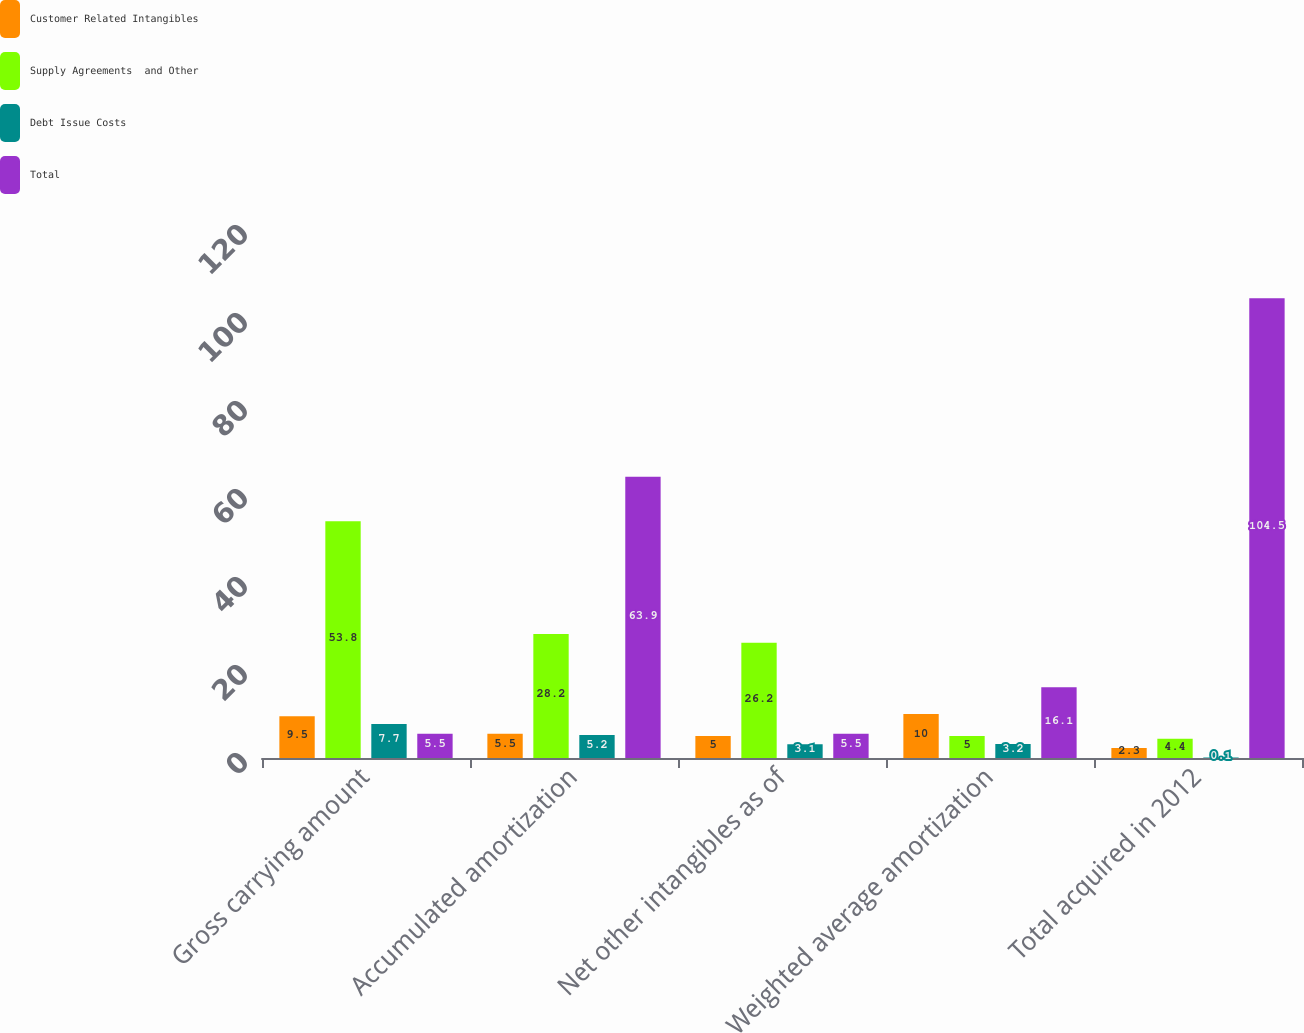Convert chart to OTSL. <chart><loc_0><loc_0><loc_500><loc_500><stacked_bar_chart><ecel><fcel>Gross carrying amount<fcel>Accumulated amortization<fcel>Net other intangibles as of<fcel>Weighted average amortization<fcel>Total acquired in 2012<nl><fcel>Customer Related Intangibles<fcel>9.5<fcel>5.5<fcel>5<fcel>10<fcel>2.3<nl><fcel>Supply Agreements  and Other<fcel>53.8<fcel>28.2<fcel>26.2<fcel>5<fcel>4.4<nl><fcel>Debt Issue Costs<fcel>7.7<fcel>5.2<fcel>3.1<fcel>3.2<fcel>0.1<nl><fcel>Total<fcel>5.5<fcel>63.9<fcel>5.5<fcel>16.1<fcel>104.5<nl></chart> 